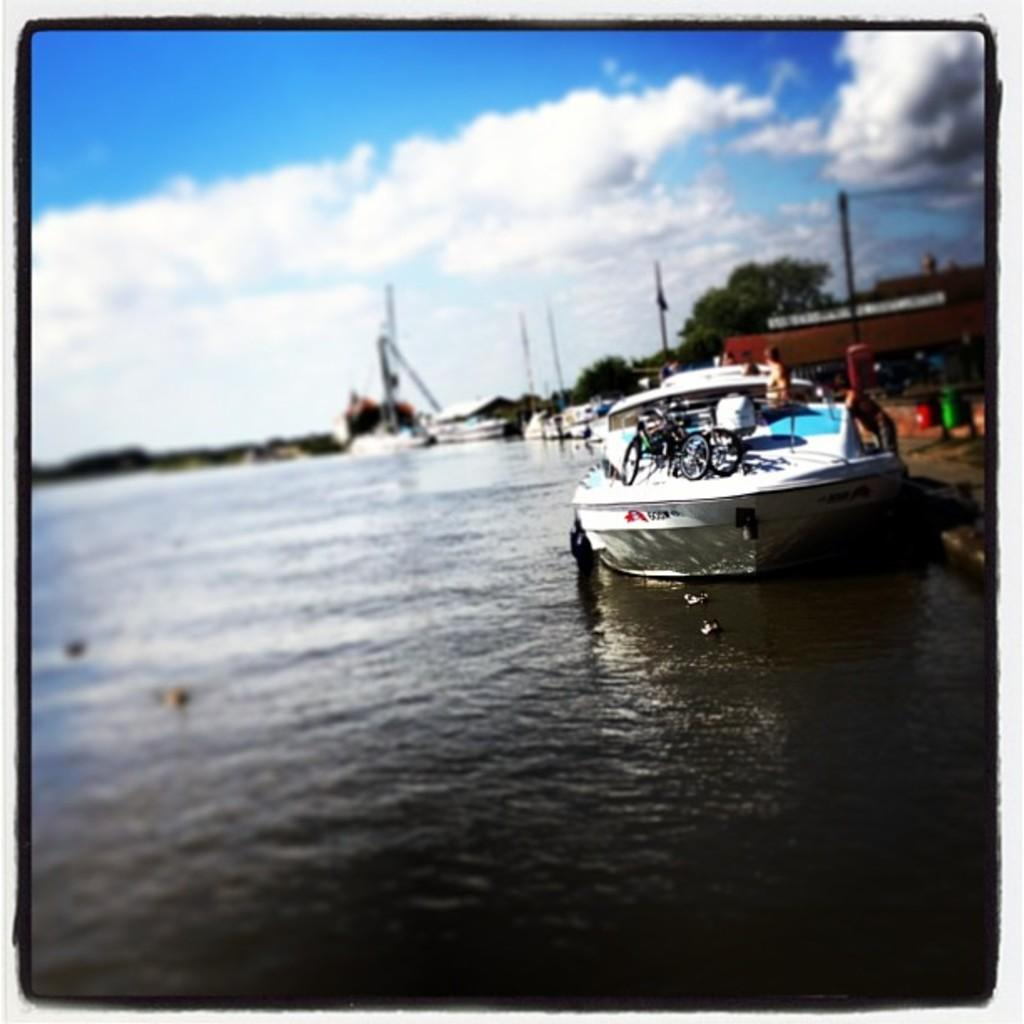What is the main element present in the image? There is water in the image. What type of vehicle can be seen in the image? There is a boat in the image. What mode of transportation is also visible in the image? There are bicycles in the image. Can you describe the people in the image? There are people in the image. What structures are present in the image? There are poles and sheds in the image. What type of vegetation can be seen in the image? There are trees in the image. What is visible in the background of the image? The sky is visible in the background of the image, and there are clouds in the sky. How many tomatoes are hanging from the poles in the image? There are no tomatoes present in the image; only poles and sheds are visible. What is the belief of the people in the image? The image does not provide any information about the beliefs of the people in the image. 